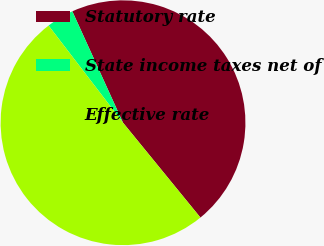Convert chart. <chart><loc_0><loc_0><loc_500><loc_500><pie_chart><fcel>Statutory rate<fcel>State income taxes net of<fcel>Effective rate<nl><fcel>45.9%<fcel>3.61%<fcel>50.49%<nl></chart> 